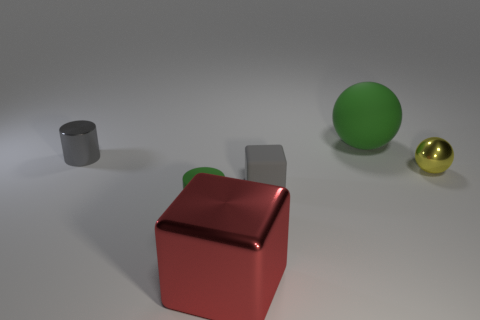Is the size of the shiny thing left of the red metal thing the same as the gray block?
Make the answer very short. Yes. How many other things are the same material as the large green ball?
Provide a short and direct response. 2. Are there more large matte objects than yellow cylinders?
Offer a terse response. Yes. What material is the gray thing that is to the right of the red metal object in front of the rubber thing left of the metallic cube made of?
Make the answer very short. Rubber. Does the rubber ball have the same color as the small shiny sphere?
Your response must be concise. No. Are there any tiny cubes of the same color as the big block?
Keep it short and to the point. No. What shape is the other metal object that is the same size as the yellow thing?
Offer a terse response. Cylinder. Are there fewer large brown matte balls than objects?
Make the answer very short. Yes. What number of gray matte balls are the same size as the gray matte object?
Give a very brief answer. 0. The small object that is the same color as the big matte sphere is what shape?
Your answer should be very brief. Cylinder. 